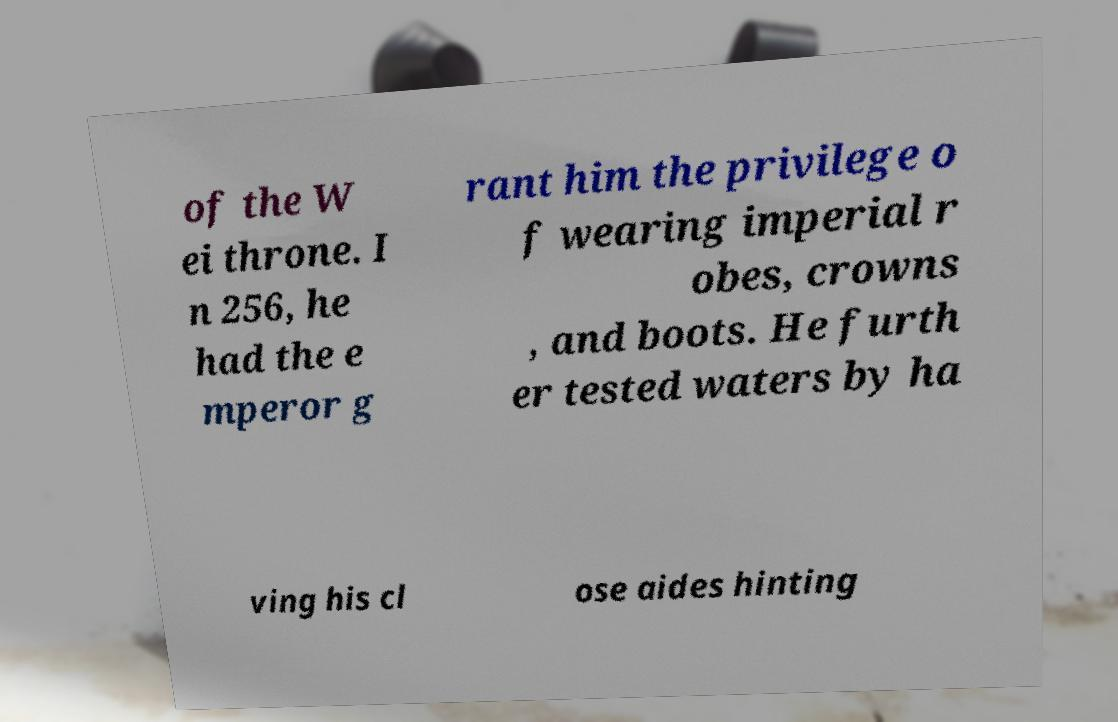What messages or text are displayed in this image? I need them in a readable, typed format. of the W ei throne. I n 256, he had the e mperor g rant him the privilege o f wearing imperial r obes, crowns , and boots. He furth er tested waters by ha ving his cl ose aides hinting 